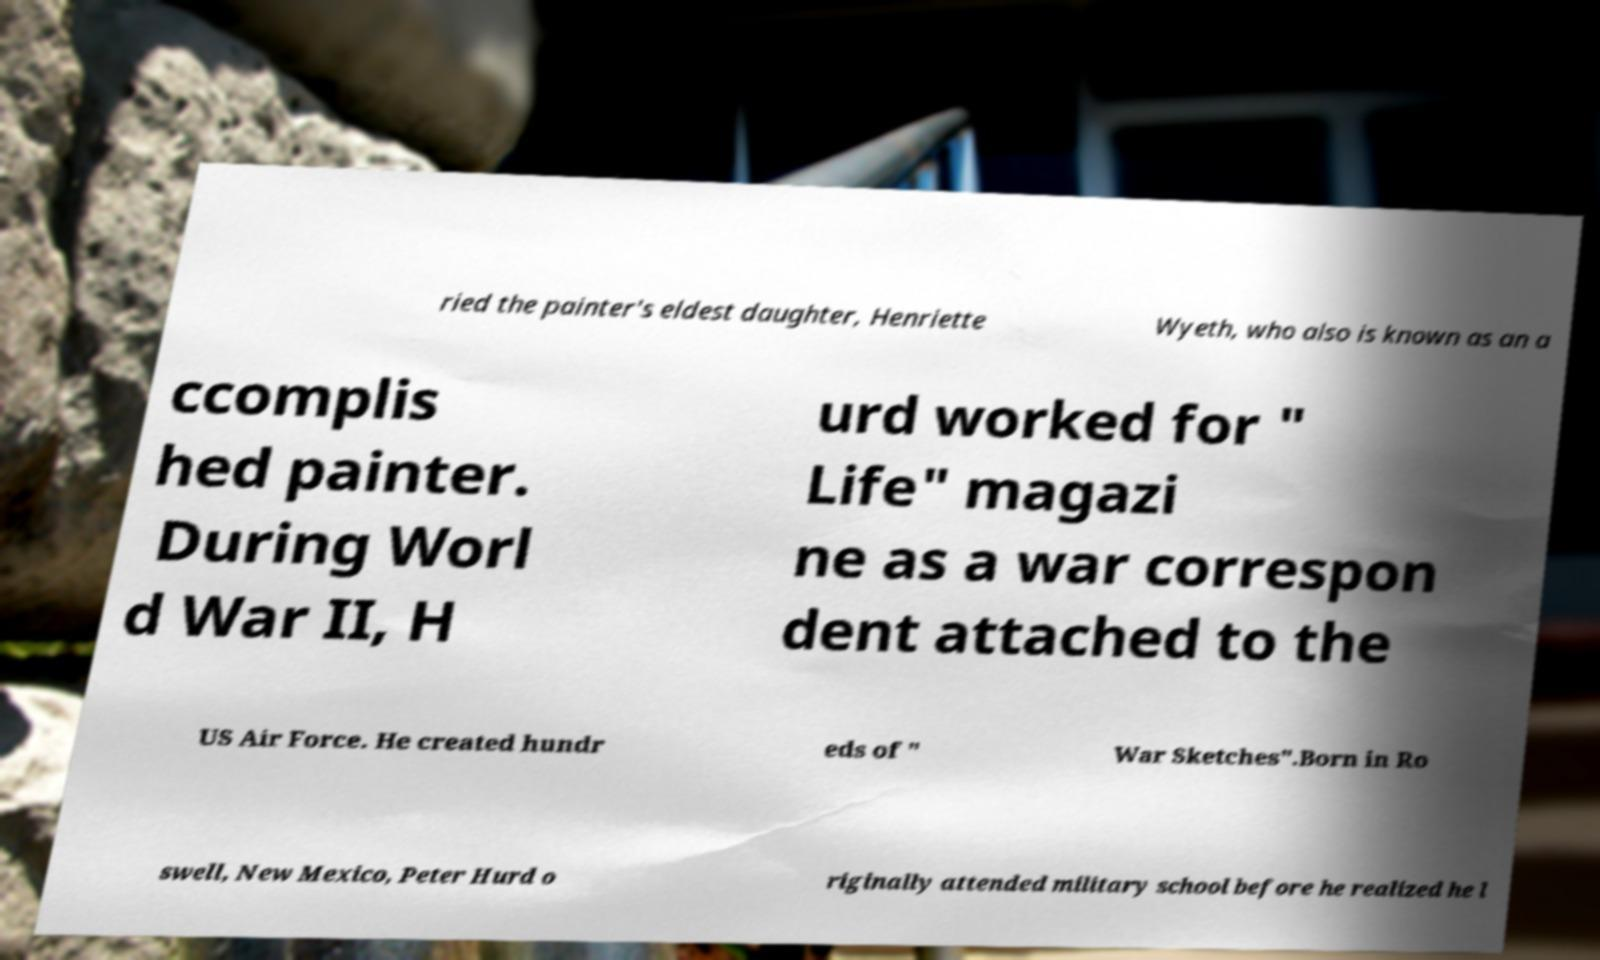Please identify and transcribe the text found in this image. ried the painter's eldest daughter, Henriette Wyeth, who also is known as an a ccomplis hed painter. During Worl d War II, H urd worked for " Life" magazi ne as a war correspon dent attached to the US Air Force. He created hundr eds of " War Sketches".Born in Ro swell, New Mexico, Peter Hurd o riginally attended military school before he realized he l 